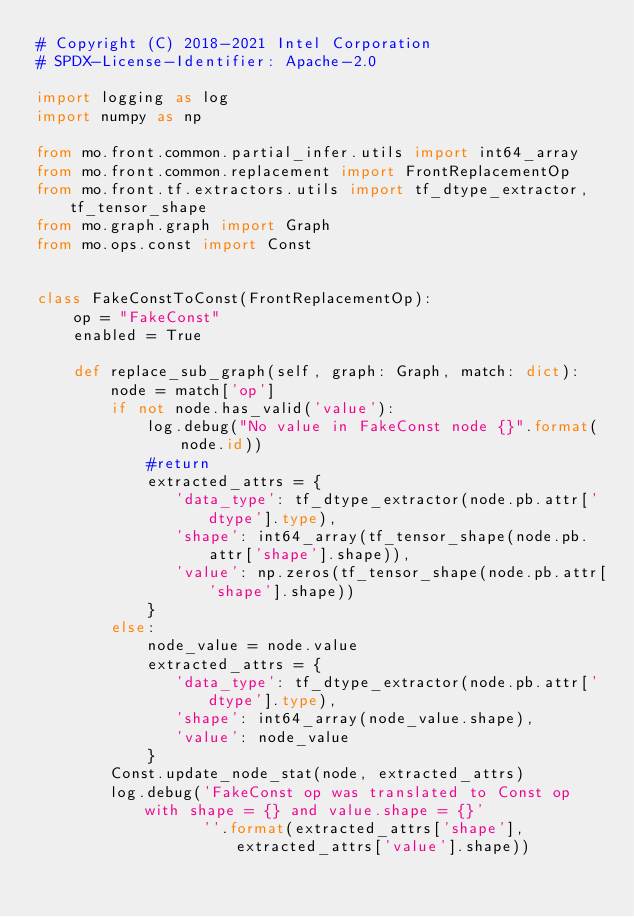Convert code to text. <code><loc_0><loc_0><loc_500><loc_500><_Python_># Copyright (C) 2018-2021 Intel Corporation
# SPDX-License-Identifier: Apache-2.0

import logging as log
import numpy as np

from mo.front.common.partial_infer.utils import int64_array
from mo.front.common.replacement import FrontReplacementOp
from mo.front.tf.extractors.utils import tf_dtype_extractor, tf_tensor_shape
from mo.graph.graph import Graph
from mo.ops.const import Const


class FakeConstToConst(FrontReplacementOp):
    op = "FakeConst"
    enabled = True

    def replace_sub_graph(self, graph: Graph, match: dict):
        node = match['op']
        if not node.has_valid('value'):
            log.debug("No value in FakeConst node {}".format(node.id))
            #return
            extracted_attrs = {
               'data_type': tf_dtype_extractor(node.pb.attr['dtype'].type),
               'shape': int64_array(tf_tensor_shape(node.pb.attr['shape'].shape)),
               'value': np.zeros(tf_tensor_shape(node.pb.attr['shape'].shape))
            }
        else:    
            node_value = node.value
            extracted_attrs = {
               'data_type': tf_dtype_extractor(node.pb.attr['dtype'].type),
               'shape': int64_array(node_value.shape),
               'value': node_value
            }
        Const.update_node_stat(node, extracted_attrs)
        log.debug('FakeConst op was translated to Const op with shape = {} and value.shape = {}'
                  ''.format(extracted_attrs['shape'], extracted_attrs['value'].shape))
</code> 